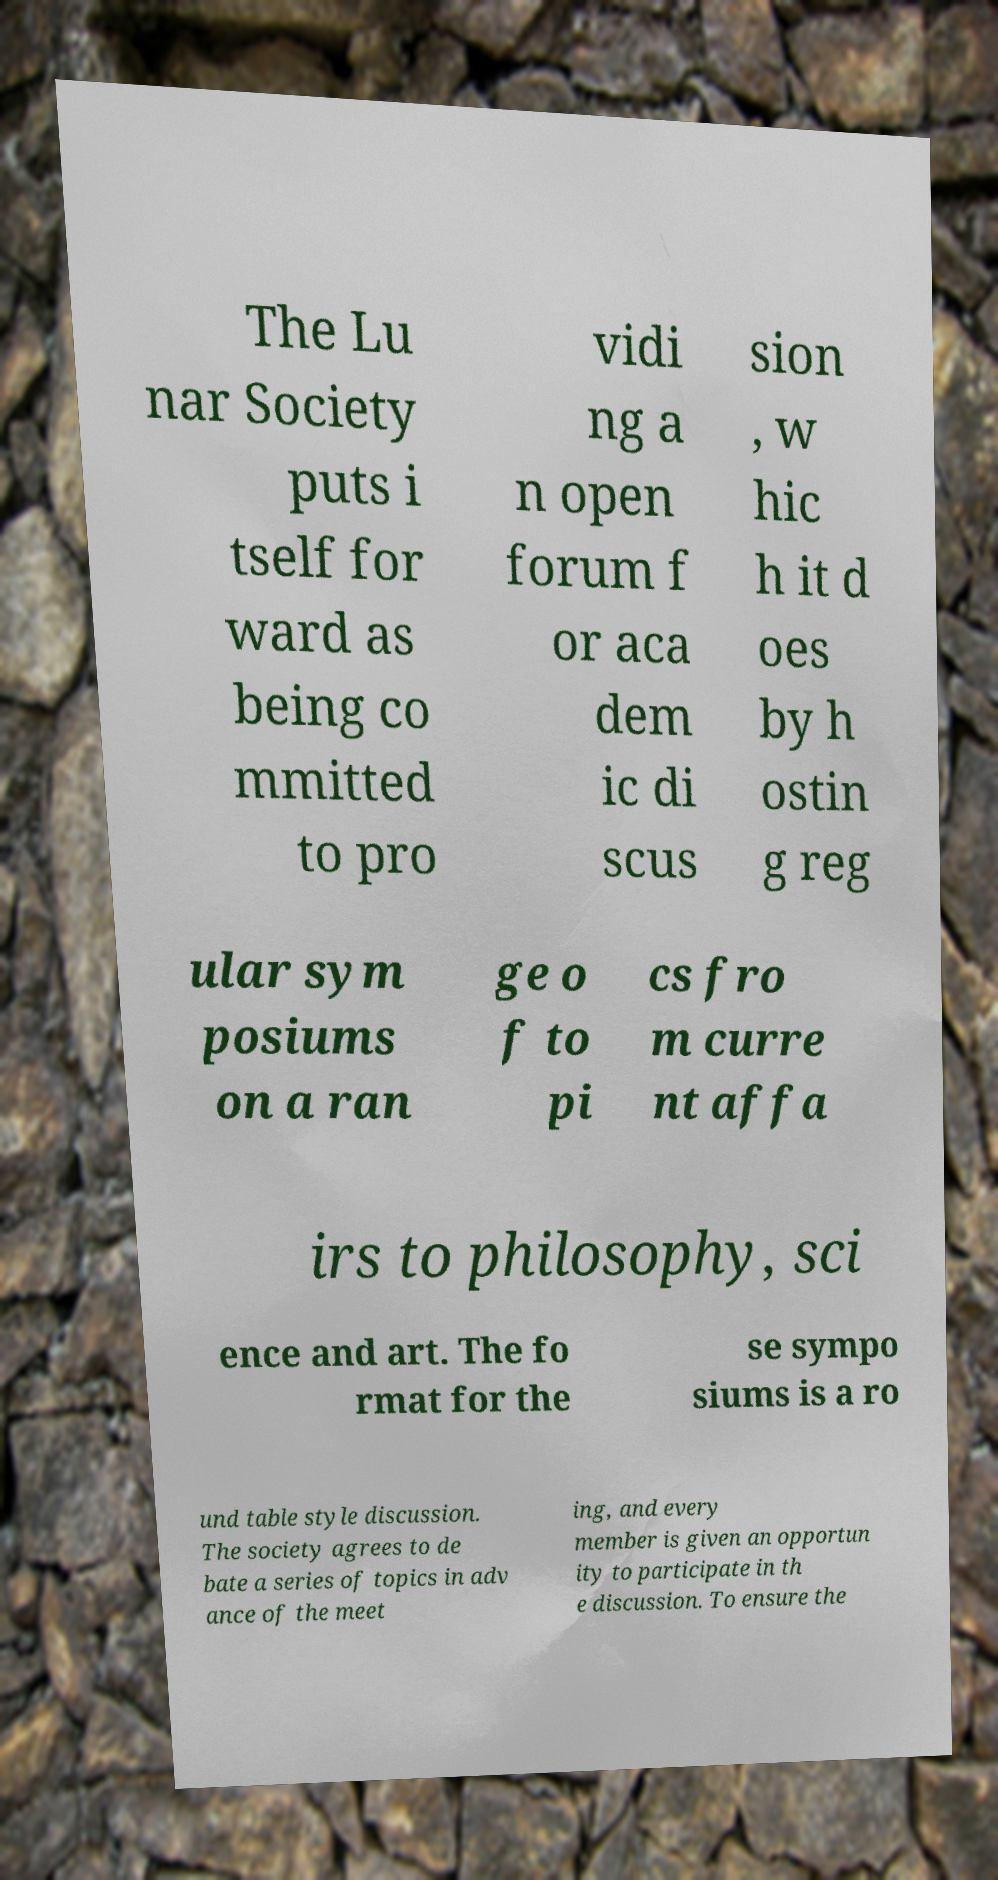For documentation purposes, I need the text within this image transcribed. Could you provide that? The Lu nar Society puts i tself for ward as being co mmitted to pro vidi ng a n open forum f or aca dem ic di scus sion , w hic h it d oes by h ostin g reg ular sym posiums on a ran ge o f to pi cs fro m curre nt affa irs to philosophy, sci ence and art. The fo rmat for the se sympo siums is a ro und table style discussion. The society agrees to de bate a series of topics in adv ance of the meet ing, and every member is given an opportun ity to participate in th e discussion. To ensure the 